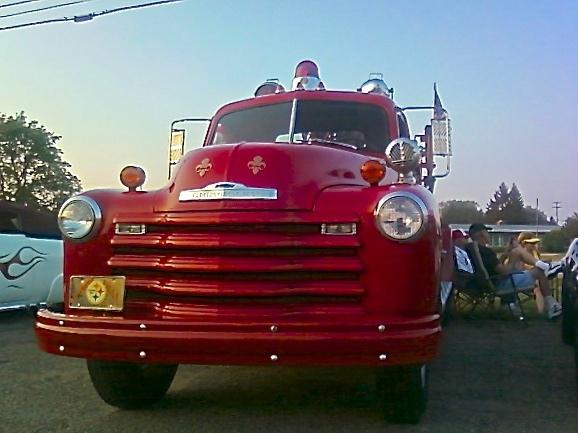What do those riding this vessel use to do their jobs? Please explain your reasoning. water. The firetruck uses water. 